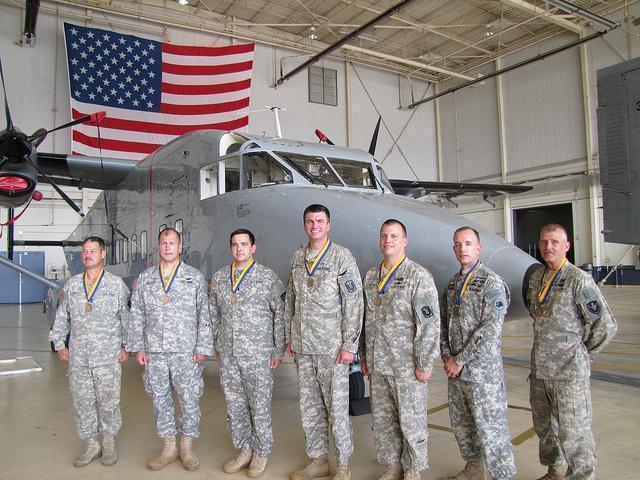How do the people know each other?
Indicate the correct response by choosing from the four available options to answer the question.
Options: Rivals, coworkers, siblings, neighbors. Coworkers. 